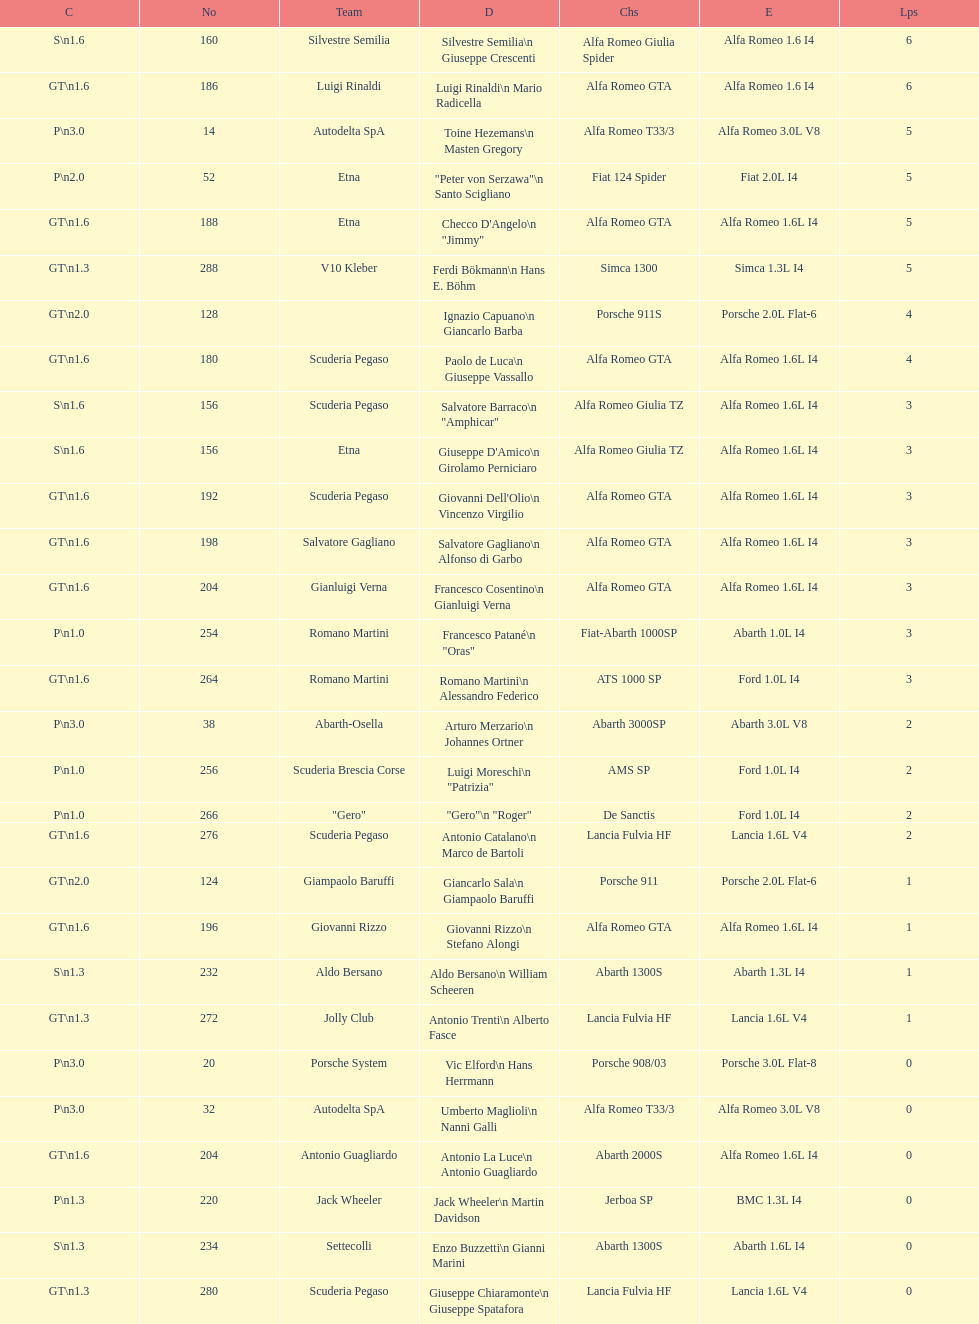How many drivers are from italy? 48. 